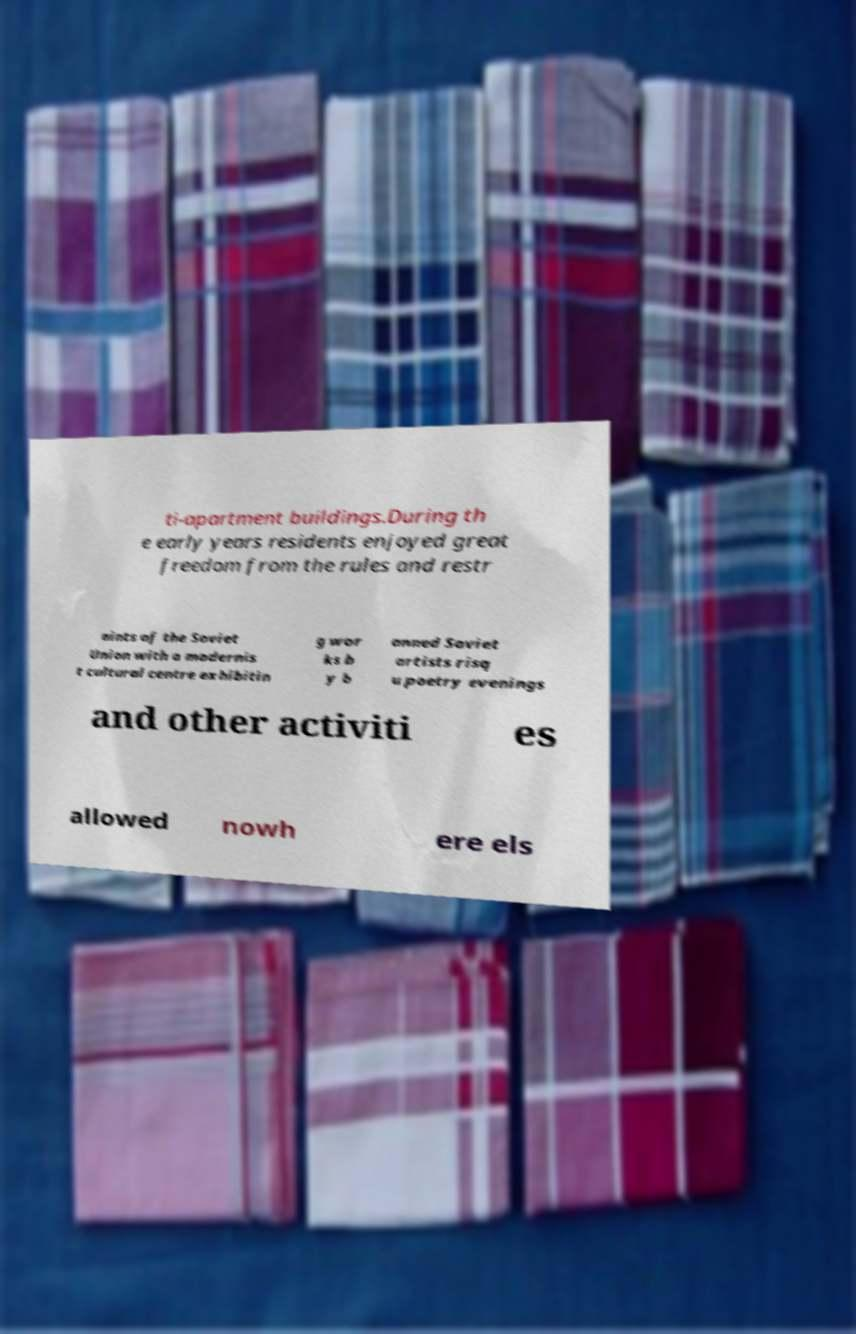There's text embedded in this image that I need extracted. Can you transcribe it verbatim? ti-apartment buildings.During th e early years residents enjoyed great freedom from the rules and restr aints of the Soviet Union with a modernis t cultural centre exhibitin g wor ks b y b anned Soviet artists risq u poetry evenings and other activiti es allowed nowh ere els 